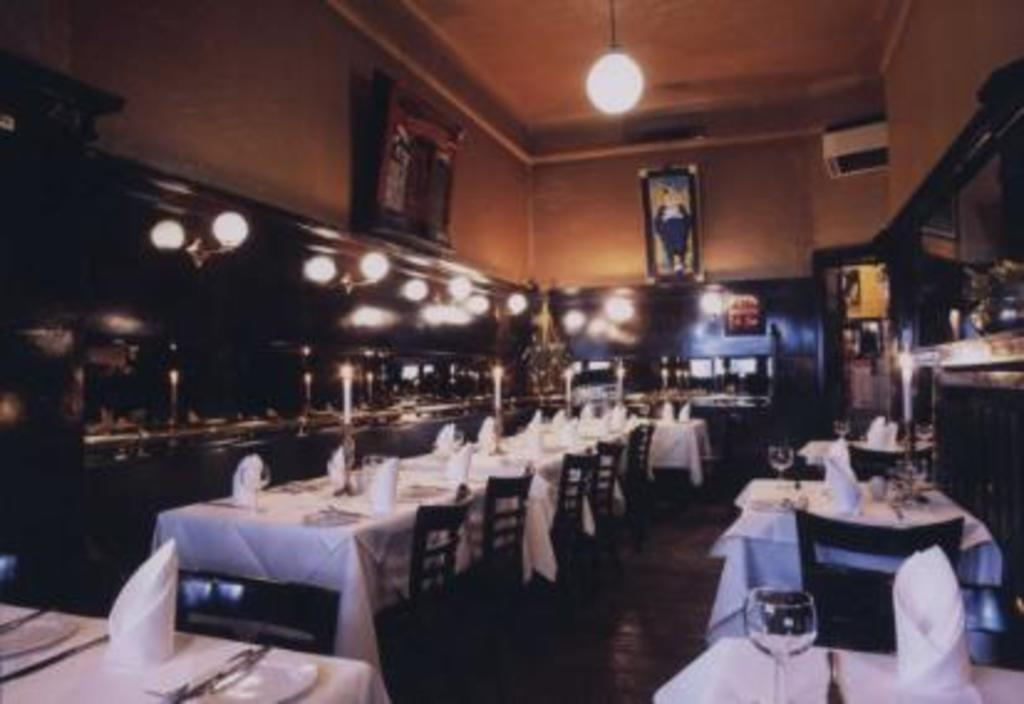What type of objects can be seen in the image? There are glasses, candles with candle stands, napkins, plates, tables, chairs, lights, and frames attached to the wall in the image. What might be used for holding food or drinks in the image? The plates and glasses in the image can be used for holding food or drinks. What type of furniture is present in the image? Tables and chairs are present in the image. What might be used for decoration or illumination in the image? The candles with candle stands and lights in the image can be used for decoration or illumination. What might be used for cleaning or wiping in the image? Napkins are present in the image for cleaning or wiping. What type of objects can be seen attached to the wall in the image? Frames are attached to the wall in the image. How many people are attending the meeting in the image? There is no meeting present in the image, and therefore no people attending it. What type of nail is being hammered into the wall in the image? There is no nail being hammered into the wall in the image. 